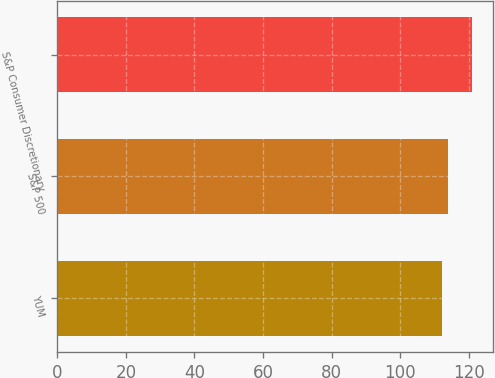Convert chart. <chart><loc_0><loc_0><loc_500><loc_500><bar_chart><fcel>YUM<fcel>S&P 500<fcel>S&P Consumer Discretionary<nl><fcel>112<fcel>114<fcel>121<nl></chart> 